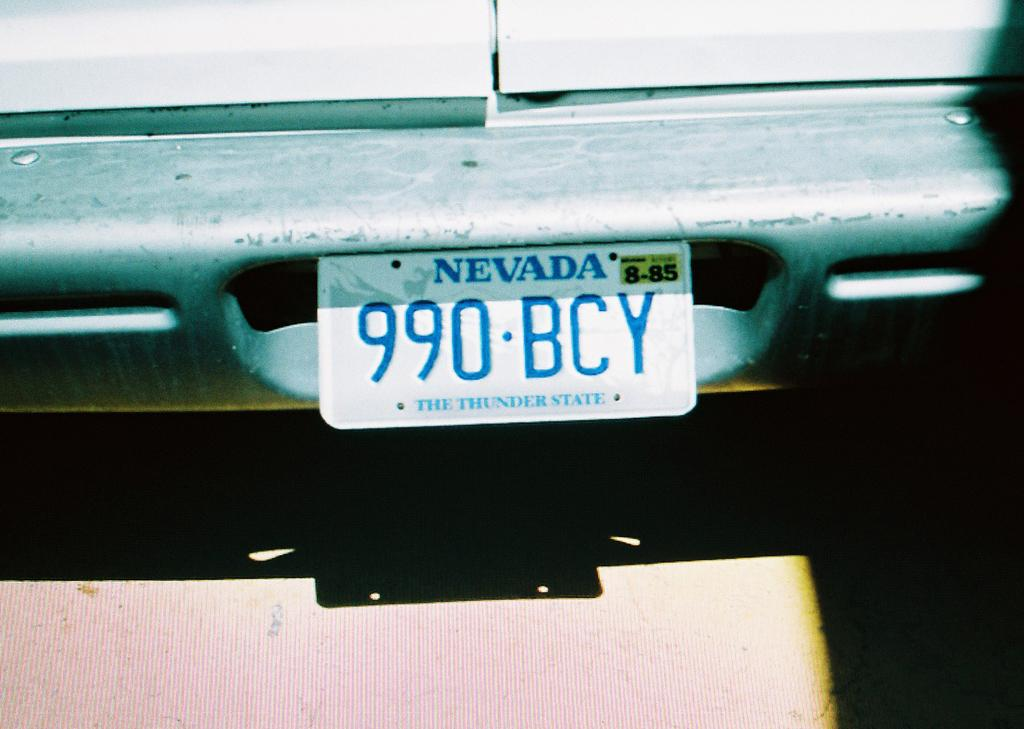<image>
Render a clear and concise summary of the photo. A Nevada tag that reads 990 BCY and expired in 85. 